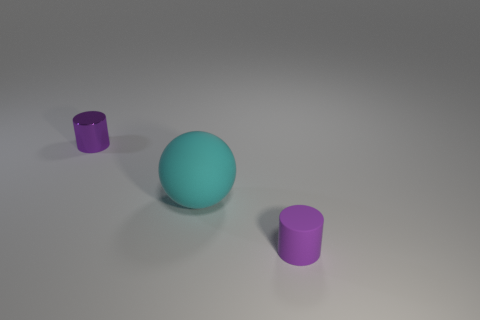What number of other purple objects are the same shape as the tiny purple matte thing?
Your response must be concise. 1. There is a small thing that is made of the same material as the large sphere; what is its shape?
Offer a very short reply. Cylinder. What number of gray things are either large things or matte things?
Keep it short and to the point. 0. There is a shiny cylinder; are there any cylinders in front of it?
Your answer should be compact. Yes. Is the shape of the small object left of the sphere the same as the big cyan object that is to the right of the small shiny thing?
Offer a very short reply. No. There is another thing that is the same shape as the purple metallic object; what is its material?
Keep it short and to the point. Rubber. What number of cubes are either cyan rubber objects or tiny metallic objects?
Give a very brief answer. 0. How many small things have the same material as the large object?
Your answer should be compact. 1. Do the object behind the big cyan sphere and the purple object that is in front of the cyan sphere have the same material?
Keep it short and to the point. No. How many small purple shiny cylinders are behind the small purple cylinder on the left side of the purple object that is in front of the tiny purple metallic cylinder?
Offer a terse response. 0. 